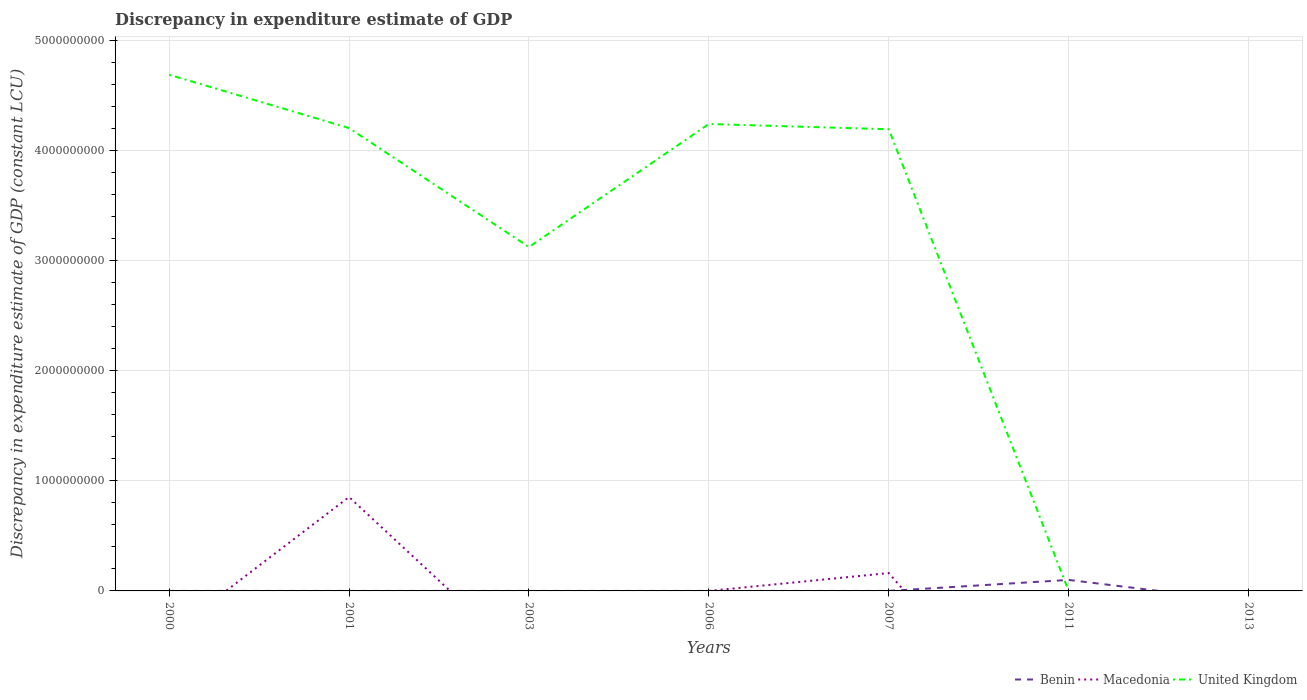How many different coloured lines are there?
Your answer should be very brief. 3. Does the line corresponding to Benin intersect with the line corresponding to Macedonia?
Offer a very short reply. Yes. Is the number of lines equal to the number of legend labels?
Offer a very short reply. No. What is the total discrepancy in expenditure estimate of GDP in United Kingdom in the graph?
Keep it short and to the point. 4.84e+08. What is the difference between the highest and the second highest discrepancy in expenditure estimate of GDP in United Kingdom?
Your answer should be compact. 4.69e+09. What is the difference between the highest and the lowest discrepancy in expenditure estimate of GDP in Benin?
Your answer should be very brief. 1. Is the discrepancy in expenditure estimate of GDP in Benin strictly greater than the discrepancy in expenditure estimate of GDP in Macedonia over the years?
Provide a short and direct response. No. How many lines are there?
Provide a short and direct response. 3. What is the difference between two consecutive major ticks on the Y-axis?
Provide a short and direct response. 1.00e+09. Does the graph contain any zero values?
Make the answer very short. Yes. Does the graph contain grids?
Ensure brevity in your answer.  Yes. How many legend labels are there?
Offer a very short reply. 3. What is the title of the graph?
Your response must be concise. Discrepancy in expenditure estimate of GDP. What is the label or title of the Y-axis?
Give a very brief answer. Discrepancy in expenditure estimate of GDP (constant LCU). What is the Discrepancy in expenditure estimate of GDP (constant LCU) in Macedonia in 2000?
Ensure brevity in your answer.  0. What is the Discrepancy in expenditure estimate of GDP (constant LCU) of United Kingdom in 2000?
Offer a terse response. 4.69e+09. What is the Discrepancy in expenditure estimate of GDP (constant LCU) in Macedonia in 2001?
Provide a succinct answer. 8.53e+08. What is the Discrepancy in expenditure estimate of GDP (constant LCU) in United Kingdom in 2001?
Provide a short and direct response. 4.20e+09. What is the Discrepancy in expenditure estimate of GDP (constant LCU) of Benin in 2003?
Your answer should be very brief. 100. What is the Discrepancy in expenditure estimate of GDP (constant LCU) of Macedonia in 2003?
Make the answer very short. 0. What is the Discrepancy in expenditure estimate of GDP (constant LCU) in United Kingdom in 2003?
Ensure brevity in your answer.  3.12e+09. What is the Discrepancy in expenditure estimate of GDP (constant LCU) in Benin in 2006?
Your answer should be very brief. 100. What is the Discrepancy in expenditure estimate of GDP (constant LCU) in Macedonia in 2006?
Provide a short and direct response. 4.69e+04. What is the Discrepancy in expenditure estimate of GDP (constant LCU) of United Kingdom in 2006?
Offer a very short reply. 4.24e+09. What is the Discrepancy in expenditure estimate of GDP (constant LCU) in Benin in 2007?
Offer a very short reply. 100. What is the Discrepancy in expenditure estimate of GDP (constant LCU) in Macedonia in 2007?
Give a very brief answer. 1.62e+08. What is the Discrepancy in expenditure estimate of GDP (constant LCU) in United Kingdom in 2007?
Your answer should be very brief. 4.19e+09. What is the Discrepancy in expenditure estimate of GDP (constant LCU) in Macedonia in 2011?
Keep it short and to the point. 0. What is the Discrepancy in expenditure estimate of GDP (constant LCU) in United Kingdom in 2011?
Ensure brevity in your answer.  1.22e+05. What is the Discrepancy in expenditure estimate of GDP (constant LCU) of Benin in 2013?
Keep it short and to the point. 0. Across all years, what is the maximum Discrepancy in expenditure estimate of GDP (constant LCU) of Benin?
Keep it short and to the point. 1.00e+08. Across all years, what is the maximum Discrepancy in expenditure estimate of GDP (constant LCU) of Macedonia?
Provide a succinct answer. 8.53e+08. Across all years, what is the maximum Discrepancy in expenditure estimate of GDP (constant LCU) in United Kingdom?
Keep it short and to the point. 4.69e+09. Across all years, what is the minimum Discrepancy in expenditure estimate of GDP (constant LCU) of Macedonia?
Your answer should be very brief. 0. Across all years, what is the minimum Discrepancy in expenditure estimate of GDP (constant LCU) of United Kingdom?
Your answer should be very brief. 0. What is the total Discrepancy in expenditure estimate of GDP (constant LCU) in Benin in the graph?
Make the answer very short. 1.00e+08. What is the total Discrepancy in expenditure estimate of GDP (constant LCU) of Macedonia in the graph?
Offer a very short reply. 1.02e+09. What is the total Discrepancy in expenditure estimate of GDP (constant LCU) of United Kingdom in the graph?
Offer a terse response. 2.04e+1. What is the difference between the Discrepancy in expenditure estimate of GDP (constant LCU) of United Kingdom in 2000 and that in 2001?
Ensure brevity in your answer.  4.84e+08. What is the difference between the Discrepancy in expenditure estimate of GDP (constant LCU) of Benin in 2000 and that in 2003?
Your response must be concise. 0. What is the difference between the Discrepancy in expenditure estimate of GDP (constant LCU) in United Kingdom in 2000 and that in 2003?
Make the answer very short. 1.56e+09. What is the difference between the Discrepancy in expenditure estimate of GDP (constant LCU) in United Kingdom in 2000 and that in 2006?
Provide a short and direct response. 4.47e+08. What is the difference between the Discrepancy in expenditure estimate of GDP (constant LCU) in United Kingdom in 2000 and that in 2007?
Your answer should be compact. 4.95e+08. What is the difference between the Discrepancy in expenditure estimate of GDP (constant LCU) in Benin in 2000 and that in 2011?
Give a very brief answer. -1.00e+08. What is the difference between the Discrepancy in expenditure estimate of GDP (constant LCU) in United Kingdom in 2000 and that in 2011?
Offer a very short reply. 4.69e+09. What is the difference between the Discrepancy in expenditure estimate of GDP (constant LCU) of Benin in 2001 and that in 2003?
Provide a succinct answer. 0. What is the difference between the Discrepancy in expenditure estimate of GDP (constant LCU) of United Kingdom in 2001 and that in 2003?
Offer a terse response. 1.08e+09. What is the difference between the Discrepancy in expenditure estimate of GDP (constant LCU) of Macedonia in 2001 and that in 2006?
Make the answer very short. 8.53e+08. What is the difference between the Discrepancy in expenditure estimate of GDP (constant LCU) of United Kingdom in 2001 and that in 2006?
Give a very brief answer. -3.67e+07. What is the difference between the Discrepancy in expenditure estimate of GDP (constant LCU) of Macedonia in 2001 and that in 2007?
Give a very brief answer. 6.91e+08. What is the difference between the Discrepancy in expenditure estimate of GDP (constant LCU) in United Kingdom in 2001 and that in 2007?
Offer a very short reply. 1.09e+07. What is the difference between the Discrepancy in expenditure estimate of GDP (constant LCU) of Benin in 2001 and that in 2011?
Ensure brevity in your answer.  -1.00e+08. What is the difference between the Discrepancy in expenditure estimate of GDP (constant LCU) of United Kingdom in 2001 and that in 2011?
Offer a terse response. 4.20e+09. What is the difference between the Discrepancy in expenditure estimate of GDP (constant LCU) of Benin in 2003 and that in 2006?
Offer a very short reply. 0. What is the difference between the Discrepancy in expenditure estimate of GDP (constant LCU) of United Kingdom in 2003 and that in 2006?
Your answer should be compact. -1.12e+09. What is the difference between the Discrepancy in expenditure estimate of GDP (constant LCU) of Benin in 2003 and that in 2007?
Your answer should be very brief. 0. What is the difference between the Discrepancy in expenditure estimate of GDP (constant LCU) of United Kingdom in 2003 and that in 2007?
Your answer should be very brief. -1.07e+09. What is the difference between the Discrepancy in expenditure estimate of GDP (constant LCU) of Benin in 2003 and that in 2011?
Give a very brief answer. -1.00e+08. What is the difference between the Discrepancy in expenditure estimate of GDP (constant LCU) in United Kingdom in 2003 and that in 2011?
Your answer should be compact. 3.12e+09. What is the difference between the Discrepancy in expenditure estimate of GDP (constant LCU) in Benin in 2006 and that in 2007?
Give a very brief answer. 0. What is the difference between the Discrepancy in expenditure estimate of GDP (constant LCU) of Macedonia in 2006 and that in 2007?
Give a very brief answer. -1.62e+08. What is the difference between the Discrepancy in expenditure estimate of GDP (constant LCU) in United Kingdom in 2006 and that in 2007?
Give a very brief answer. 4.76e+07. What is the difference between the Discrepancy in expenditure estimate of GDP (constant LCU) of Benin in 2006 and that in 2011?
Provide a short and direct response. -1.00e+08. What is the difference between the Discrepancy in expenditure estimate of GDP (constant LCU) of United Kingdom in 2006 and that in 2011?
Your response must be concise. 4.24e+09. What is the difference between the Discrepancy in expenditure estimate of GDP (constant LCU) of Benin in 2007 and that in 2011?
Make the answer very short. -1.00e+08. What is the difference between the Discrepancy in expenditure estimate of GDP (constant LCU) of United Kingdom in 2007 and that in 2011?
Your answer should be compact. 4.19e+09. What is the difference between the Discrepancy in expenditure estimate of GDP (constant LCU) in Benin in 2000 and the Discrepancy in expenditure estimate of GDP (constant LCU) in Macedonia in 2001?
Offer a very short reply. -8.53e+08. What is the difference between the Discrepancy in expenditure estimate of GDP (constant LCU) of Benin in 2000 and the Discrepancy in expenditure estimate of GDP (constant LCU) of United Kingdom in 2001?
Offer a terse response. -4.20e+09. What is the difference between the Discrepancy in expenditure estimate of GDP (constant LCU) of Benin in 2000 and the Discrepancy in expenditure estimate of GDP (constant LCU) of United Kingdom in 2003?
Ensure brevity in your answer.  -3.12e+09. What is the difference between the Discrepancy in expenditure estimate of GDP (constant LCU) of Benin in 2000 and the Discrepancy in expenditure estimate of GDP (constant LCU) of Macedonia in 2006?
Your answer should be compact. -4.68e+04. What is the difference between the Discrepancy in expenditure estimate of GDP (constant LCU) in Benin in 2000 and the Discrepancy in expenditure estimate of GDP (constant LCU) in United Kingdom in 2006?
Make the answer very short. -4.24e+09. What is the difference between the Discrepancy in expenditure estimate of GDP (constant LCU) of Benin in 2000 and the Discrepancy in expenditure estimate of GDP (constant LCU) of Macedonia in 2007?
Your answer should be compact. -1.62e+08. What is the difference between the Discrepancy in expenditure estimate of GDP (constant LCU) of Benin in 2000 and the Discrepancy in expenditure estimate of GDP (constant LCU) of United Kingdom in 2007?
Offer a terse response. -4.19e+09. What is the difference between the Discrepancy in expenditure estimate of GDP (constant LCU) of Benin in 2000 and the Discrepancy in expenditure estimate of GDP (constant LCU) of United Kingdom in 2011?
Your answer should be compact. -1.22e+05. What is the difference between the Discrepancy in expenditure estimate of GDP (constant LCU) in Benin in 2001 and the Discrepancy in expenditure estimate of GDP (constant LCU) in United Kingdom in 2003?
Your answer should be very brief. -3.12e+09. What is the difference between the Discrepancy in expenditure estimate of GDP (constant LCU) in Macedonia in 2001 and the Discrepancy in expenditure estimate of GDP (constant LCU) in United Kingdom in 2003?
Your answer should be compact. -2.27e+09. What is the difference between the Discrepancy in expenditure estimate of GDP (constant LCU) in Benin in 2001 and the Discrepancy in expenditure estimate of GDP (constant LCU) in Macedonia in 2006?
Provide a short and direct response. -4.68e+04. What is the difference between the Discrepancy in expenditure estimate of GDP (constant LCU) of Benin in 2001 and the Discrepancy in expenditure estimate of GDP (constant LCU) of United Kingdom in 2006?
Provide a succinct answer. -4.24e+09. What is the difference between the Discrepancy in expenditure estimate of GDP (constant LCU) of Macedonia in 2001 and the Discrepancy in expenditure estimate of GDP (constant LCU) of United Kingdom in 2006?
Keep it short and to the point. -3.39e+09. What is the difference between the Discrepancy in expenditure estimate of GDP (constant LCU) of Benin in 2001 and the Discrepancy in expenditure estimate of GDP (constant LCU) of Macedonia in 2007?
Your answer should be compact. -1.62e+08. What is the difference between the Discrepancy in expenditure estimate of GDP (constant LCU) in Benin in 2001 and the Discrepancy in expenditure estimate of GDP (constant LCU) in United Kingdom in 2007?
Provide a short and direct response. -4.19e+09. What is the difference between the Discrepancy in expenditure estimate of GDP (constant LCU) of Macedonia in 2001 and the Discrepancy in expenditure estimate of GDP (constant LCU) of United Kingdom in 2007?
Ensure brevity in your answer.  -3.34e+09. What is the difference between the Discrepancy in expenditure estimate of GDP (constant LCU) in Benin in 2001 and the Discrepancy in expenditure estimate of GDP (constant LCU) in United Kingdom in 2011?
Offer a very short reply. -1.22e+05. What is the difference between the Discrepancy in expenditure estimate of GDP (constant LCU) of Macedonia in 2001 and the Discrepancy in expenditure estimate of GDP (constant LCU) of United Kingdom in 2011?
Ensure brevity in your answer.  8.53e+08. What is the difference between the Discrepancy in expenditure estimate of GDP (constant LCU) in Benin in 2003 and the Discrepancy in expenditure estimate of GDP (constant LCU) in Macedonia in 2006?
Provide a short and direct response. -4.68e+04. What is the difference between the Discrepancy in expenditure estimate of GDP (constant LCU) of Benin in 2003 and the Discrepancy in expenditure estimate of GDP (constant LCU) of United Kingdom in 2006?
Offer a very short reply. -4.24e+09. What is the difference between the Discrepancy in expenditure estimate of GDP (constant LCU) in Benin in 2003 and the Discrepancy in expenditure estimate of GDP (constant LCU) in Macedonia in 2007?
Your response must be concise. -1.62e+08. What is the difference between the Discrepancy in expenditure estimate of GDP (constant LCU) of Benin in 2003 and the Discrepancy in expenditure estimate of GDP (constant LCU) of United Kingdom in 2007?
Offer a very short reply. -4.19e+09. What is the difference between the Discrepancy in expenditure estimate of GDP (constant LCU) of Benin in 2003 and the Discrepancy in expenditure estimate of GDP (constant LCU) of United Kingdom in 2011?
Ensure brevity in your answer.  -1.22e+05. What is the difference between the Discrepancy in expenditure estimate of GDP (constant LCU) in Benin in 2006 and the Discrepancy in expenditure estimate of GDP (constant LCU) in Macedonia in 2007?
Make the answer very short. -1.62e+08. What is the difference between the Discrepancy in expenditure estimate of GDP (constant LCU) in Benin in 2006 and the Discrepancy in expenditure estimate of GDP (constant LCU) in United Kingdom in 2007?
Provide a short and direct response. -4.19e+09. What is the difference between the Discrepancy in expenditure estimate of GDP (constant LCU) in Macedonia in 2006 and the Discrepancy in expenditure estimate of GDP (constant LCU) in United Kingdom in 2007?
Make the answer very short. -4.19e+09. What is the difference between the Discrepancy in expenditure estimate of GDP (constant LCU) of Benin in 2006 and the Discrepancy in expenditure estimate of GDP (constant LCU) of United Kingdom in 2011?
Your response must be concise. -1.22e+05. What is the difference between the Discrepancy in expenditure estimate of GDP (constant LCU) of Macedonia in 2006 and the Discrepancy in expenditure estimate of GDP (constant LCU) of United Kingdom in 2011?
Give a very brief answer. -7.55e+04. What is the difference between the Discrepancy in expenditure estimate of GDP (constant LCU) of Benin in 2007 and the Discrepancy in expenditure estimate of GDP (constant LCU) of United Kingdom in 2011?
Offer a very short reply. -1.22e+05. What is the difference between the Discrepancy in expenditure estimate of GDP (constant LCU) of Macedonia in 2007 and the Discrepancy in expenditure estimate of GDP (constant LCU) of United Kingdom in 2011?
Your answer should be very brief. 1.62e+08. What is the average Discrepancy in expenditure estimate of GDP (constant LCU) in Benin per year?
Make the answer very short. 1.43e+07. What is the average Discrepancy in expenditure estimate of GDP (constant LCU) of Macedonia per year?
Make the answer very short. 1.45e+08. What is the average Discrepancy in expenditure estimate of GDP (constant LCU) in United Kingdom per year?
Ensure brevity in your answer.  2.92e+09. In the year 2000, what is the difference between the Discrepancy in expenditure estimate of GDP (constant LCU) in Benin and Discrepancy in expenditure estimate of GDP (constant LCU) in United Kingdom?
Provide a succinct answer. -4.69e+09. In the year 2001, what is the difference between the Discrepancy in expenditure estimate of GDP (constant LCU) in Benin and Discrepancy in expenditure estimate of GDP (constant LCU) in Macedonia?
Your answer should be compact. -8.53e+08. In the year 2001, what is the difference between the Discrepancy in expenditure estimate of GDP (constant LCU) in Benin and Discrepancy in expenditure estimate of GDP (constant LCU) in United Kingdom?
Keep it short and to the point. -4.20e+09. In the year 2001, what is the difference between the Discrepancy in expenditure estimate of GDP (constant LCU) of Macedonia and Discrepancy in expenditure estimate of GDP (constant LCU) of United Kingdom?
Ensure brevity in your answer.  -3.35e+09. In the year 2003, what is the difference between the Discrepancy in expenditure estimate of GDP (constant LCU) of Benin and Discrepancy in expenditure estimate of GDP (constant LCU) of United Kingdom?
Make the answer very short. -3.12e+09. In the year 2006, what is the difference between the Discrepancy in expenditure estimate of GDP (constant LCU) of Benin and Discrepancy in expenditure estimate of GDP (constant LCU) of Macedonia?
Offer a very short reply. -4.68e+04. In the year 2006, what is the difference between the Discrepancy in expenditure estimate of GDP (constant LCU) in Benin and Discrepancy in expenditure estimate of GDP (constant LCU) in United Kingdom?
Provide a short and direct response. -4.24e+09. In the year 2006, what is the difference between the Discrepancy in expenditure estimate of GDP (constant LCU) in Macedonia and Discrepancy in expenditure estimate of GDP (constant LCU) in United Kingdom?
Ensure brevity in your answer.  -4.24e+09. In the year 2007, what is the difference between the Discrepancy in expenditure estimate of GDP (constant LCU) of Benin and Discrepancy in expenditure estimate of GDP (constant LCU) of Macedonia?
Give a very brief answer. -1.62e+08. In the year 2007, what is the difference between the Discrepancy in expenditure estimate of GDP (constant LCU) of Benin and Discrepancy in expenditure estimate of GDP (constant LCU) of United Kingdom?
Offer a very short reply. -4.19e+09. In the year 2007, what is the difference between the Discrepancy in expenditure estimate of GDP (constant LCU) of Macedonia and Discrepancy in expenditure estimate of GDP (constant LCU) of United Kingdom?
Keep it short and to the point. -4.03e+09. In the year 2011, what is the difference between the Discrepancy in expenditure estimate of GDP (constant LCU) in Benin and Discrepancy in expenditure estimate of GDP (constant LCU) in United Kingdom?
Your answer should be compact. 9.99e+07. What is the ratio of the Discrepancy in expenditure estimate of GDP (constant LCU) of Benin in 2000 to that in 2001?
Offer a terse response. 1. What is the ratio of the Discrepancy in expenditure estimate of GDP (constant LCU) of United Kingdom in 2000 to that in 2001?
Make the answer very short. 1.12. What is the ratio of the Discrepancy in expenditure estimate of GDP (constant LCU) in United Kingdom in 2000 to that in 2003?
Your answer should be very brief. 1.5. What is the ratio of the Discrepancy in expenditure estimate of GDP (constant LCU) of United Kingdom in 2000 to that in 2006?
Keep it short and to the point. 1.11. What is the ratio of the Discrepancy in expenditure estimate of GDP (constant LCU) in United Kingdom in 2000 to that in 2007?
Keep it short and to the point. 1.12. What is the ratio of the Discrepancy in expenditure estimate of GDP (constant LCU) in Benin in 2000 to that in 2011?
Provide a short and direct response. 0. What is the ratio of the Discrepancy in expenditure estimate of GDP (constant LCU) in United Kingdom in 2000 to that in 2011?
Your response must be concise. 3.83e+04. What is the ratio of the Discrepancy in expenditure estimate of GDP (constant LCU) in United Kingdom in 2001 to that in 2003?
Give a very brief answer. 1.35. What is the ratio of the Discrepancy in expenditure estimate of GDP (constant LCU) of Benin in 2001 to that in 2006?
Your response must be concise. 1. What is the ratio of the Discrepancy in expenditure estimate of GDP (constant LCU) of Macedonia in 2001 to that in 2006?
Keep it short and to the point. 1.82e+04. What is the ratio of the Discrepancy in expenditure estimate of GDP (constant LCU) of Benin in 2001 to that in 2007?
Your response must be concise. 1. What is the ratio of the Discrepancy in expenditure estimate of GDP (constant LCU) of Macedonia in 2001 to that in 2007?
Offer a very short reply. 5.26. What is the ratio of the Discrepancy in expenditure estimate of GDP (constant LCU) of United Kingdom in 2001 to that in 2011?
Offer a very short reply. 3.43e+04. What is the ratio of the Discrepancy in expenditure estimate of GDP (constant LCU) of United Kingdom in 2003 to that in 2006?
Provide a short and direct response. 0.74. What is the ratio of the Discrepancy in expenditure estimate of GDP (constant LCU) in United Kingdom in 2003 to that in 2007?
Ensure brevity in your answer.  0.74. What is the ratio of the Discrepancy in expenditure estimate of GDP (constant LCU) of United Kingdom in 2003 to that in 2011?
Give a very brief answer. 2.55e+04. What is the ratio of the Discrepancy in expenditure estimate of GDP (constant LCU) of United Kingdom in 2006 to that in 2007?
Make the answer very short. 1.01. What is the ratio of the Discrepancy in expenditure estimate of GDP (constant LCU) in Benin in 2006 to that in 2011?
Your response must be concise. 0. What is the ratio of the Discrepancy in expenditure estimate of GDP (constant LCU) in United Kingdom in 2006 to that in 2011?
Keep it short and to the point. 3.46e+04. What is the ratio of the Discrepancy in expenditure estimate of GDP (constant LCU) of United Kingdom in 2007 to that in 2011?
Provide a succinct answer. 3.43e+04. What is the difference between the highest and the second highest Discrepancy in expenditure estimate of GDP (constant LCU) of Benin?
Keep it short and to the point. 1.00e+08. What is the difference between the highest and the second highest Discrepancy in expenditure estimate of GDP (constant LCU) in Macedonia?
Ensure brevity in your answer.  6.91e+08. What is the difference between the highest and the second highest Discrepancy in expenditure estimate of GDP (constant LCU) of United Kingdom?
Your answer should be very brief. 4.47e+08. What is the difference between the highest and the lowest Discrepancy in expenditure estimate of GDP (constant LCU) in Macedonia?
Provide a short and direct response. 8.53e+08. What is the difference between the highest and the lowest Discrepancy in expenditure estimate of GDP (constant LCU) of United Kingdom?
Provide a short and direct response. 4.69e+09. 